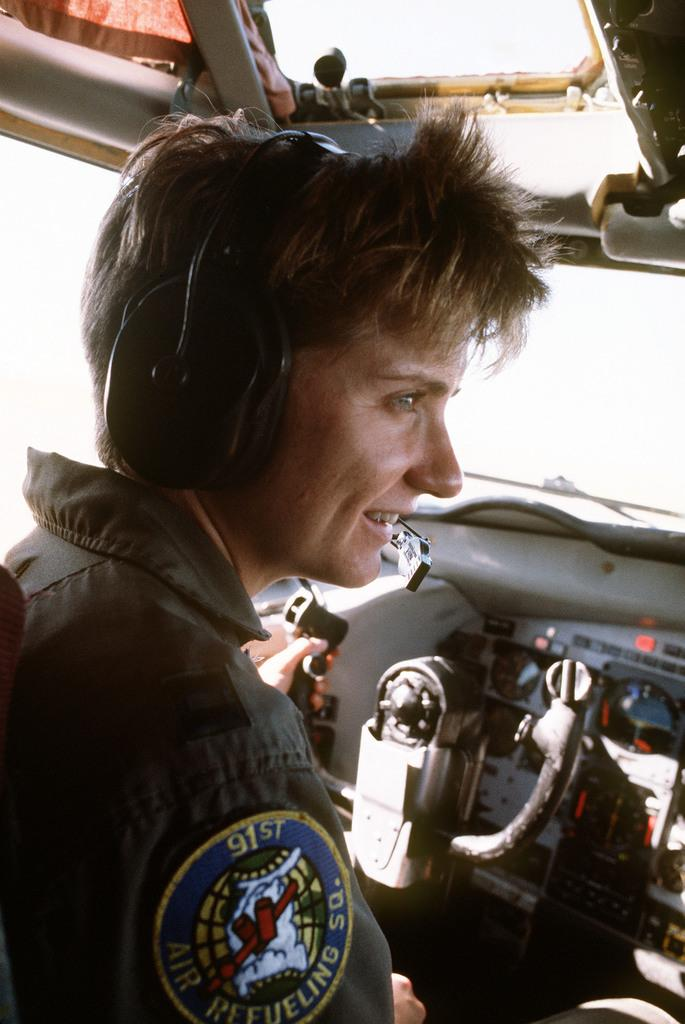What is the main subject of the image? The main subject of the image is a woman. Where is the woman located? The woman is in an aircraft. What is the woman wearing? The woman is wearing a dress and a headset. What expression does the woman have? The woman is smiling. What type of birds can be seen flying outside the aircraft in the image? There are no birds visible in the image; it only shows a woman in an aircraft. 